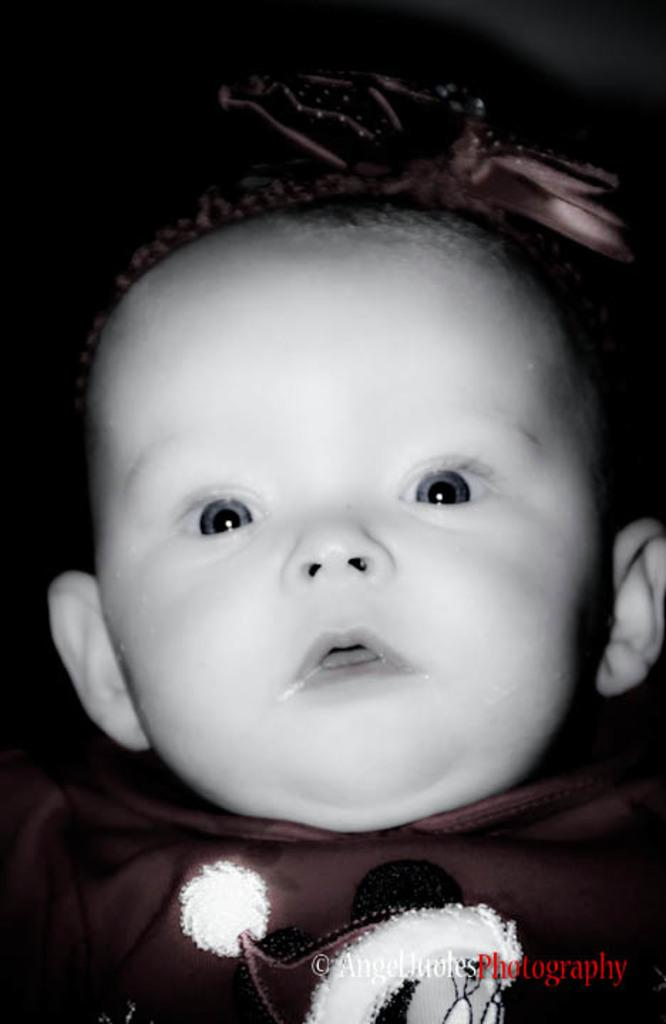What is the main subject of the image? The main subject of the image is a baby. Is there any text present in the image? Yes, there is some text at the right bottom of the image. What type of power source is visible in the image? There is no power source visible in the image; it features a baby and some text. What type of bean is present in the image? There is no bean present in the image. 